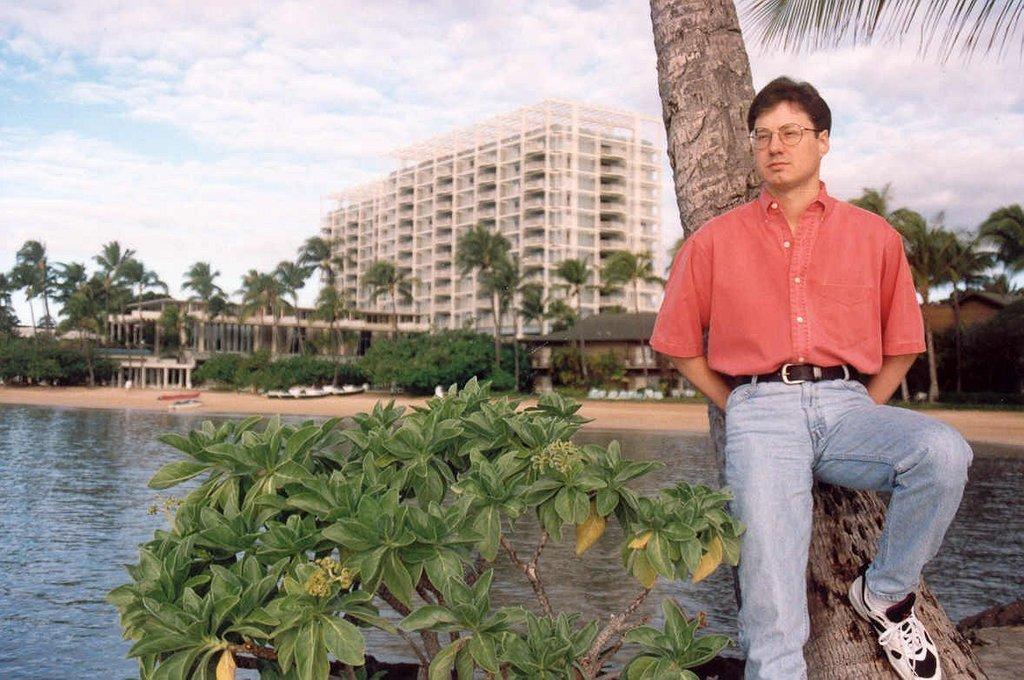Could you give a brief overview of what you see in this image? In this image we can see a man wearing glasses and standing. In the background we can see the building, trees, houses and also the boats on the surface. We can also see the water. There is sky with the clouds. 